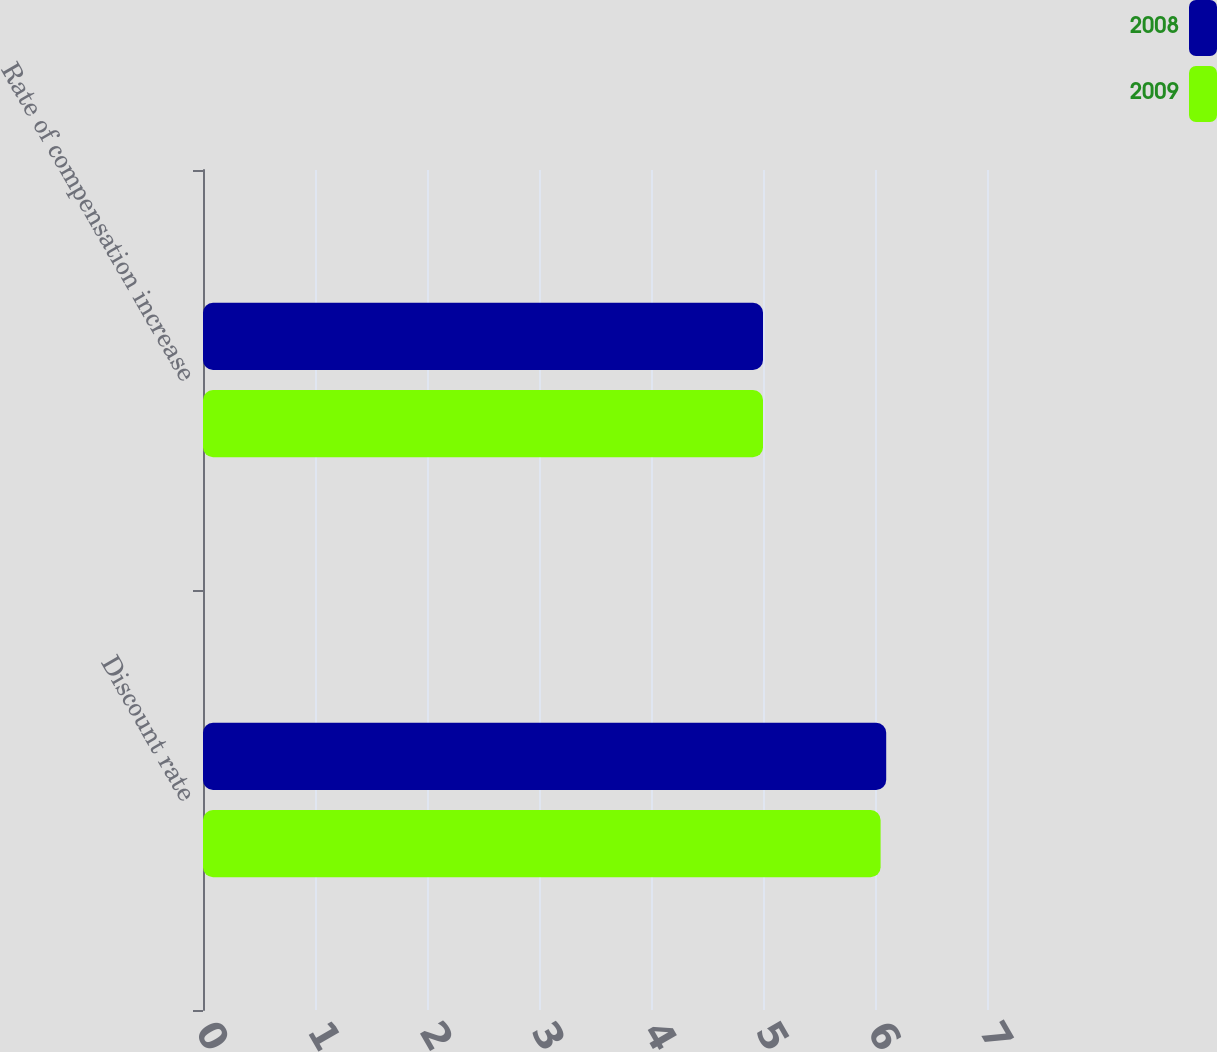<chart> <loc_0><loc_0><loc_500><loc_500><stacked_bar_chart><ecel><fcel>Discount rate<fcel>Rate of compensation increase<nl><fcel>2008<fcel>6.1<fcel>5<nl><fcel>2009<fcel>6.05<fcel>5<nl></chart> 